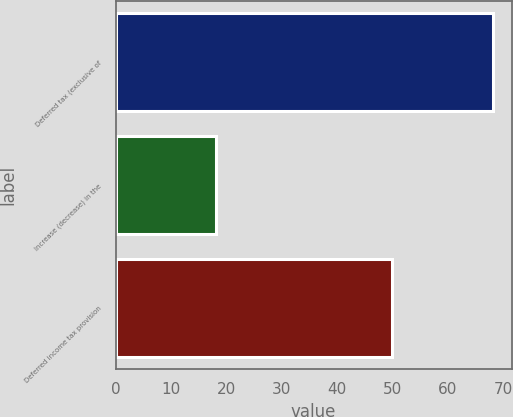Convert chart. <chart><loc_0><loc_0><loc_500><loc_500><bar_chart><fcel>Deferred tax (exclusive of<fcel>Increase (decrease) in the<fcel>Deferred income tax provision<nl><fcel>68.1<fcel>18.2<fcel>49.9<nl></chart> 